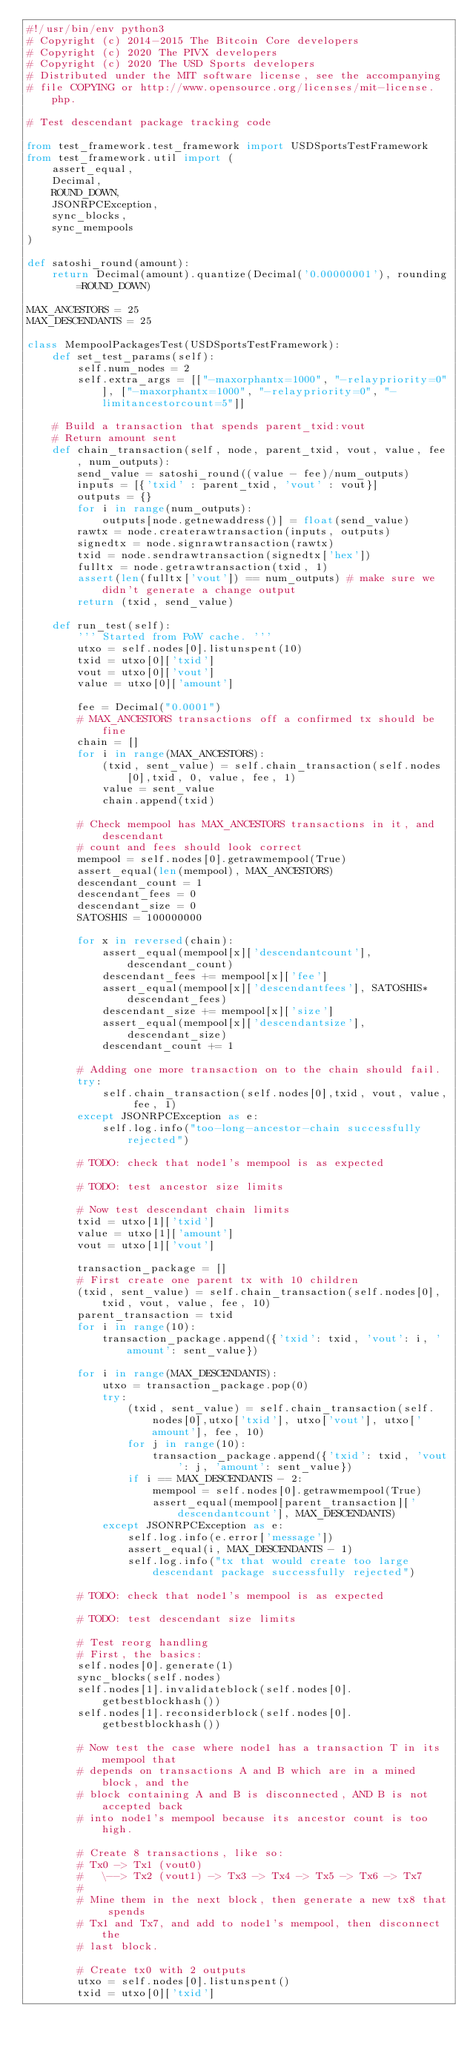Convert code to text. <code><loc_0><loc_0><loc_500><loc_500><_Python_>#!/usr/bin/env python3
# Copyright (c) 2014-2015 The Bitcoin Core developers
# Copyright (c) 2020 The PIVX developers
# Copyright (c) 2020 The USD Sports developers
# Distributed under the MIT software license, see the accompanying
# file COPYING or http://www.opensource.org/licenses/mit-license.php.

# Test descendant package tracking code

from test_framework.test_framework import USDSportsTestFramework
from test_framework.util import (
    assert_equal,
    Decimal,
    ROUND_DOWN,
    JSONRPCException,
    sync_blocks,
    sync_mempools
)

def satoshi_round(amount):
    return Decimal(amount).quantize(Decimal('0.00000001'), rounding=ROUND_DOWN)

MAX_ANCESTORS = 25
MAX_DESCENDANTS = 25

class MempoolPackagesTest(USDSportsTestFramework):
    def set_test_params(self):
        self.num_nodes = 2
        self.extra_args = [["-maxorphantx=1000", "-relaypriority=0"], ["-maxorphantx=1000", "-relaypriority=0", "-limitancestorcount=5"]]

    # Build a transaction that spends parent_txid:vout
    # Return amount sent
    def chain_transaction(self, node, parent_txid, vout, value, fee, num_outputs):
        send_value = satoshi_round((value - fee)/num_outputs)
        inputs = [{'txid' : parent_txid, 'vout' : vout}]
        outputs = {}
        for i in range(num_outputs):
            outputs[node.getnewaddress()] = float(send_value)
        rawtx = node.createrawtransaction(inputs, outputs)
        signedtx = node.signrawtransaction(rawtx)
        txid = node.sendrawtransaction(signedtx['hex'])
        fulltx = node.getrawtransaction(txid, 1)
        assert(len(fulltx['vout']) == num_outputs) # make sure we didn't generate a change output
        return (txid, send_value)

    def run_test(self):
        ''' Started from PoW cache. '''
        utxo = self.nodes[0].listunspent(10)
        txid = utxo[0]['txid']
        vout = utxo[0]['vout']
        value = utxo[0]['amount']

        fee = Decimal("0.0001")
        # MAX_ANCESTORS transactions off a confirmed tx should be fine
        chain = []
        for i in range(MAX_ANCESTORS):
            (txid, sent_value) = self.chain_transaction(self.nodes[0],txid, 0, value, fee, 1)
            value = sent_value
            chain.append(txid)

        # Check mempool has MAX_ANCESTORS transactions in it, and descendant
        # count and fees should look correct
        mempool = self.nodes[0].getrawmempool(True)
        assert_equal(len(mempool), MAX_ANCESTORS)
        descendant_count = 1
        descendant_fees = 0
        descendant_size = 0
        SATOSHIS = 100000000

        for x in reversed(chain):
            assert_equal(mempool[x]['descendantcount'], descendant_count)
            descendant_fees += mempool[x]['fee']
            assert_equal(mempool[x]['descendantfees'], SATOSHIS*descendant_fees)
            descendant_size += mempool[x]['size']
            assert_equal(mempool[x]['descendantsize'], descendant_size)
            descendant_count += 1

        # Adding one more transaction on to the chain should fail.
        try:
            self.chain_transaction(self.nodes[0],txid, vout, value, fee, 1)
        except JSONRPCException as e:
            self.log.info("too-long-ancestor-chain successfully rejected")

        # TODO: check that node1's mempool is as expected

        # TODO: test ancestor size limits

        # Now test descendant chain limits
        txid = utxo[1]['txid']
        value = utxo[1]['amount']
        vout = utxo[1]['vout']

        transaction_package = []
        # First create one parent tx with 10 children
        (txid, sent_value) = self.chain_transaction(self.nodes[0],txid, vout, value, fee, 10)
        parent_transaction = txid
        for i in range(10):
            transaction_package.append({'txid': txid, 'vout': i, 'amount': sent_value})

        for i in range(MAX_DESCENDANTS):
            utxo = transaction_package.pop(0)
            try:
                (txid, sent_value) = self.chain_transaction(self.nodes[0],utxo['txid'], utxo['vout'], utxo['amount'], fee, 10)
                for j in range(10):
                    transaction_package.append({'txid': txid, 'vout': j, 'amount': sent_value})
                if i == MAX_DESCENDANTS - 2:
                    mempool = self.nodes[0].getrawmempool(True)
                    assert_equal(mempool[parent_transaction]['descendantcount'], MAX_DESCENDANTS)
            except JSONRPCException as e:
                self.log.info(e.error['message'])
                assert_equal(i, MAX_DESCENDANTS - 1)
                self.log.info("tx that would create too large descendant package successfully rejected")

        # TODO: check that node1's mempool is as expected

        # TODO: test descendant size limits

        # Test reorg handling
        # First, the basics:
        self.nodes[0].generate(1)
        sync_blocks(self.nodes)
        self.nodes[1].invalidateblock(self.nodes[0].getbestblockhash())
        self.nodes[1].reconsiderblock(self.nodes[0].getbestblockhash())

        # Now test the case where node1 has a transaction T in its mempool that
        # depends on transactions A and B which are in a mined block, and the
        # block containing A and B is disconnected, AND B is not accepted back
        # into node1's mempool because its ancestor count is too high.

        # Create 8 transactions, like so:
        # Tx0 -> Tx1 (vout0)
        #   \--> Tx2 (vout1) -> Tx3 -> Tx4 -> Tx5 -> Tx6 -> Tx7
        #
        # Mine them in the next block, then generate a new tx8 that spends
        # Tx1 and Tx7, and add to node1's mempool, then disconnect the
        # last block.

        # Create tx0 with 2 outputs
        utxo = self.nodes[0].listunspent()
        txid = utxo[0]['txid']</code> 